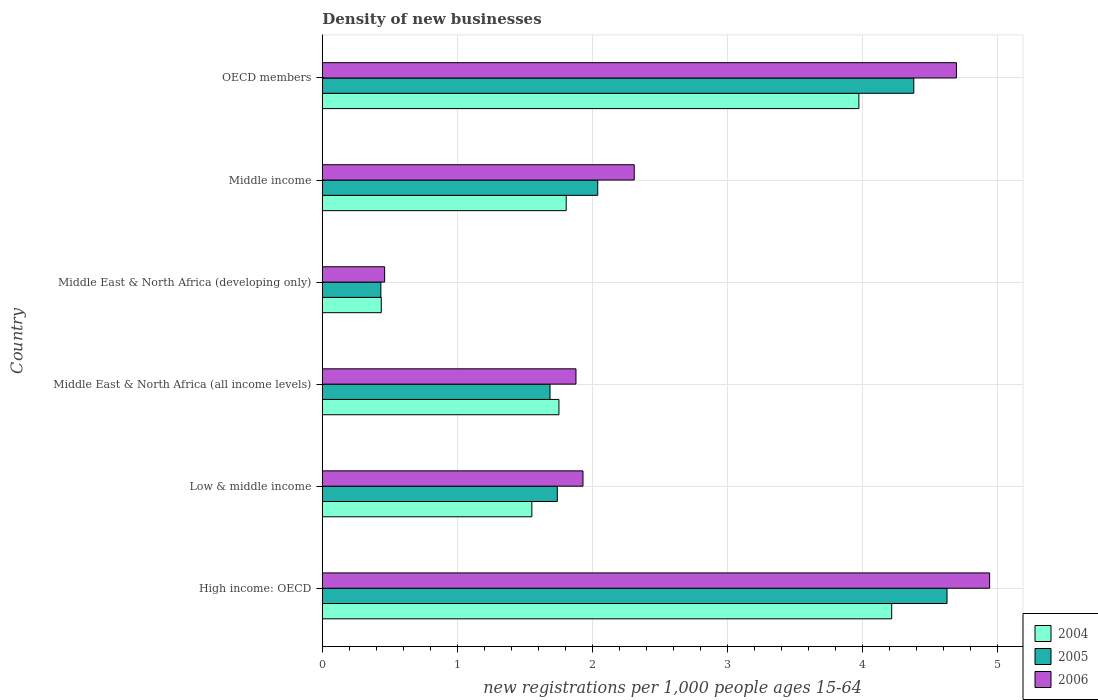Are the number of bars on each tick of the Y-axis equal?
Make the answer very short. Yes. What is the number of new registrations in 2005 in Low & middle income?
Your answer should be very brief. 1.74. Across all countries, what is the maximum number of new registrations in 2004?
Provide a short and direct response. 4.22. Across all countries, what is the minimum number of new registrations in 2006?
Your answer should be very brief. 0.46. In which country was the number of new registrations in 2005 maximum?
Make the answer very short. High income: OECD. In which country was the number of new registrations in 2005 minimum?
Provide a succinct answer. Middle East & North Africa (developing only). What is the total number of new registrations in 2006 in the graph?
Provide a short and direct response. 16.23. What is the difference between the number of new registrations in 2005 in Low & middle income and that in Middle East & North Africa (developing only)?
Give a very brief answer. 1.31. What is the difference between the number of new registrations in 2005 in Middle income and the number of new registrations in 2006 in OECD members?
Provide a short and direct response. -2.66. What is the average number of new registrations in 2006 per country?
Your answer should be compact. 2.7. What is the difference between the number of new registrations in 2004 and number of new registrations in 2005 in High income: OECD?
Give a very brief answer. -0.41. What is the ratio of the number of new registrations in 2005 in Middle East & North Africa (developing only) to that in OECD members?
Make the answer very short. 0.1. Is the number of new registrations in 2004 in Middle East & North Africa (developing only) less than that in Middle income?
Offer a terse response. Yes. What is the difference between the highest and the second highest number of new registrations in 2005?
Ensure brevity in your answer.  0.25. What is the difference between the highest and the lowest number of new registrations in 2004?
Your answer should be very brief. 3.78. Is the sum of the number of new registrations in 2005 in Low & middle income and Middle East & North Africa (developing only) greater than the maximum number of new registrations in 2006 across all countries?
Offer a terse response. No. What does the 3rd bar from the top in Middle East & North Africa (developing only) represents?
Ensure brevity in your answer.  2004. Is it the case that in every country, the sum of the number of new registrations in 2005 and number of new registrations in 2004 is greater than the number of new registrations in 2006?
Offer a terse response. Yes. Are all the bars in the graph horizontal?
Ensure brevity in your answer.  Yes. How many countries are there in the graph?
Give a very brief answer. 6. What is the difference between two consecutive major ticks on the X-axis?
Provide a succinct answer. 1. Where does the legend appear in the graph?
Give a very brief answer. Bottom right. What is the title of the graph?
Your answer should be very brief. Density of new businesses. What is the label or title of the X-axis?
Offer a very short reply. New registrations per 1,0 people ages 15-64. What is the label or title of the Y-axis?
Offer a terse response. Country. What is the new registrations per 1,000 people ages 15-64 in 2004 in High income: OECD?
Give a very brief answer. 4.22. What is the new registrations per 1,000 people ages 15-64 of 2005 in High income: OECD?
Provide a succinct answer. 4.63. What is the new registrations per 1,000 people ages 15-64 of 2006 in High income: OECD?
Provide a short and direct response. 4.94. What is the new registrations per 1,000 people ages 15-64 in 2004 in Low & middle income?
Offer a terse response. 1.55. What is the new registrations per 1,000 people ages 15-64 in 2005 in Low & middle income?
Your response must be concise. 1.74. What is the new registrations per 1,000 people ages 15-64 of 2006 in Low & middle income?
Your answer should be very brief. 1.93. What is the new registrations per 1,000 people ages 15-64 of 2004 in Middle East & North Africa (all income levels)?
Make the answer very short. 1.75. What is the new registrations per 1,000 people ages 15-64 of 2005 in Middle East & North Africa (all income levels)?
Provide a succinct answer. 1.69. What is the new registrations per 1,000 people ages 15-64 in 2006 in Middle East & North Africa (all income levels)?
Make the answer very short. 1.88. What is the new registrations per 1,000 people ages 15-64 in 2004 in Middle East & North Africa (developing only)?
Provide a short and direct response. 0.44. What is the new registrations per 1,000 people ages 15-64 of 2005 in Middle East & North Africa (developing only)?
Your answer should be very brief. 0.43. What is the new registrations per 1,000 people ages 15-64 of 2006 in Middle East & North Africa (developing only)?
Keep it short and to the point. 0.46. What is the new registrations per 1,000 people ages 15-64 in 2004 in Middle income?
Your response must be concise. 1.81. What is the new registrations per 1,000 people ages 15-64 of 2005 in Middle income?
Provide a short and direct response. 2.04. What is the new registrations per 1,000 people ages 15-64 of 2006 in Middle income?
Provide a short and direct response. 2.31. What is the new registrations per 1,000 people ages 15-64 of 2004 in OECD members?
Your answer should be very brief. 3.98. What is the new registrations per 1,000 people ages 15-64 in 2005 in OECD members?
Ensure brevity in your answer.  4.38. What is the new registrations per 1,000 people ages 15-64 in 2006 in OECD members?
Ensure brevity in your answer.  4.7. Across all countries, what is the maximum new registrations per 1,000 people ages 15-64 in 2004?
Offer a terse response. 4.22. Across all countries, what is the maximum new registrations per 1,000 people ages 15-64 of 2005?
Offer a very short reply. 4.63. Across all countries, what is the maximum new registrations per 1,000 people ages 15-64 of 2006?
Provide a short and direct response. 4.94. Across all countries, what is the minimum new registrations per 1,000 people ages 15-64 in 2004?
Your answer should be very brief. 0.44. Across all countries, what is the minimum new registrations per 1,000 people ages 15-64 of 2005?
Your response must be concise. 0.43. Across all countries, what is the minimum new registrations per 1,000 people ages 15-64 of 2006?
Your response must be concise. 0.46. What is the total new registrations per 1,000 people ages 15-64 of 2004 in the graph?
Offer a terse response. 13.74. What is the total new registrations per 1,000 people ages 15-64 of 2005 in the graph?
Your answer should be compact. 14.92. What is the total new registrations per 1,000 people ages 15-64 in 2006 in the graph?
Your answer should be very brief. 16.23. What is the difference between the new registrations per 1,000 people ages 15-64 of 2004 in High income: OECD and that in Low & middle income?
Your response must be concise. 2.67. What is the difference between the new registrations per 1,000 people ages 15-64 in 2005 in High income: OECD and that in Low & middle income?
Offer a terse response. 2.89. What is the difference between the new registrations per 1,000 people ages 15-64 in 2006 in High income: OECD and that in Low & middle income?
Provide a succinct answer. 3.01. What is the difference between the new registrations per 1,000 people ages 15-64 in 2004 in High income: OECD and that in Middle East & North Africa (all income levels)?
Your answer should be compact. 2.47. What is the difference between the new registrations per 1,000 people ages 15-64 of 2005 in High income: OECD and that in Middle East & North Africa (all income levels)?
Give a very brief answer. 2.94. What is the difference between the new registrations per 1,000 people ages 15-64 in 2006 in High income: OECD and that in Middle East & North Africa (all income levels)?
Provide a succinct answer. 3.07. What is the difference between the new registrations per 1,000 people ages 15-64 of 2004 in High income: OECD and that in Middle East & North Africa (developing only)?
Offer a terse response. 3.78. What is the difference between the new registrations per 1,000 people ages 15-64 of 2005 in High income: OECD and that in Middle East & North Africa (developing only)?
Provide a succinct answer. 4.2. What is the difference between the new registrations per 1,000 people ages 15-64 in 2006 in High income: OECD and that in Middle East & North Africa (developing only)?
Keep it short and to the point. 4.48. What is the difference between the new registrations per 1,000 people ages 15-64 in 2004 in High income: OECD and that in Middle income?
Your answer should be compact. 2.41. What is the difference between the new registrations per 1,000 people ages 15-64 in 2005 in High income: OECD and that in Middle income?
Offer a terse response. 2.59. What is the difference between the new registrations per 1,000 people ages 15-64 in 2006 in High income: OECD and that in Middle income?
Offer a very short reply. 2.63. What is the difference between the new registrations per 1,000 people ages 15-64 in 2004 in High income: OECD and that in OECD members?
Give a very brief answer. 0.24. What is the difference between the new registrations per 1,000 people ages 15-64 in 2005 in High income: OECD and that in OECD members?
Provide a succinct answer. 0.25. What is the difference between the new registrations per 1,000 people ages 15-64 in 2006 in High income: OECD and that in OECD members?
Keep it short and to the point. 0.25. What is the difference between the new registrations per 1,000 people ages 15-64 of 2004 in Low & middle income and that in Middle East & North Africa (all income levels)?
Offer a terse response. -0.2. What is the difference between the new registrations per 1,000 people ages 15-64 in 2005 in Low & middle income and that in Middle East & North Africa (all income levels)?
Give a very brief answer. 0.05. What is the difference between the new registrations per 1,000 people ages 15-64 of 2006 in Low & middle income and that in Middle East & North Africa (all income levels)?
Keep it short and to the point. 0.05. What is the difference between the new registrations per 1,000 people ages 15-64 of 2004 in Low & middle income and that in Middle East & North Africa (developing only)?
Give a very brief answer. 1.12. What is the difference between the new registrations per 1,000 people ages 15-64 of 2005 in Low & middle income and that in Middle East & North Africa (developing only)?
Keep it short and to the point. 1.31. What is the difference between the new registrations per 1,000 people ages 15-64 in 2006 in Low & middle income and that in Middle East & North Africa (developing only)?
Provide a succinct answer. 1.47. What is the difference between the new registrations per 1,000 people ages 15-64 of 2004 in Low & middle income and that in Middle income?
Offer a terse response. -0.25. What is the difference between the new registrations per 1,000 people ages 15-64 in 2005 in Low & middle income and that in Middle income?
Provide a succinct answer. -0.3. What is the difference between the new registrations per 1,000 people ages 15-64 of 2006 in Low & middle income and that in Middle income?
Offer a terse response. -0.38. What is the difference between the new registrations per 1,000 people ages 15-64 in 2004 in Low & middle income and that in OECD members?
Your answer should be very brief. -2.42. What is the difference between the new registrations per 1,000 people ages 15-64 of 2005 in Low & middle income and that in OECD members?
Provide a short and direct response. -2.64. What is the difference between the new registrations per 1,000 people ages 15-64 in 2006 in Low & middle income and that in OECD members?
Ensure brevity in your answer.  -2.77. What is the difference between the new registrations per 1,000 people ages 15-64 of 2004 in Middle East & North Africa (all income levels) and that in Middle East & North Africa (developing only)?
Provide a short and direct response. 1.32. What is the difference between the new registrations per 1,000 people ages 15-64 of 2005 in Middle East & North Africa (all income levels) and that in Middle East & North Africa (developing only)?
Ensure brevity in your answer.  1.25. What is the difference between the new registrations per 1,000 people ages 15-64 of 2006 in Middle East & North Africa (all income levels) and that in Middle East & North Africa (developing only)?
Provide a succinct answer. 1.42. What is the difference between the new registrations per 1,000 people ages 15-64 in 2004 in Middle East & North Africa (all income levels) and that in Middle income?
Provide a short and direct response. -0.05. What is the difference between the new registrations per 1,000 people ages 15-64 of 2005 in Middle East & North Africa (all income levels) and that in Middle income?
Offer a very short reply. -0.35. What is the difference between the new registrations per 1,000 people ages 15-64 in 2006 in Middle East & North Africa (all income levels) and that in Middle income?
Make the answer very short. -0.43. What is the difference between the new registrations per 1,000 people ages 15-64 in 2004 in Middle East & North Africa (all income levels) and that in OECD members?
Provide a succinct answer. -2.22. What is the difference between the new registrations per 1,000 people ages 15-64 of 2005 in Middle East & North Africa (all income levels) and that in OECD members?
Give a very brief answer. -2.7. What is the difference between the new registrations per 1,000 people ages 15-64 in 2006 in Middle East & North Africa (all income levels) and that in OECD members?
Give a very brief answer. -2.82. What is the difference between the new registrations per 1,000 people ages 15-64 in 2004 in Middle East & North Africa (developing only) and that in Middle income?
Ensure brevity in your answer.  -1.37. What is the difference between the new registrations per 1,000 people ages 15-64 of 2005 in Middle East & North Africa (developing only) and that in Middle income?
Your response must be concise. -1.61. What is the difference between the new registrations per 1,000 people ages 15-64 in 2006 in Middle East & North Africa (developing only) and that in Middle income?
Keep it short and to the point. -1.85. What is the difference between the new registrations per 1,000 people ages 15-64 of 2004 in Middle East & North Africa (developing only) and that in OECD members?
Your answer should be compact. -3.54. What is the difference between the new registrations per 1,000 people ages 15-64 in 2005 in Middle East & North Africa (developing only) and that in OECD members?
Offer a very short reply. -3.95. What is the difference between the new registrations per 1,000 people ages 15-64 in 2006 in Middle East & North Africa (developing only) and that in OECD members?
Offer a terse response. -4.24. What is the difference between the new registrations per 1,000 people ages 15-64 in 2004 in Middle income and that in OECD members?
Your response must be concise. -2.17. What is the difference between the new registrations per 1,000 people ages 15-64 of 2005 in Middle income and that in OECD members?
Offer a terse response. -2.34. What is the difference between the new registrations per 1,000 people ages 15-64 in 2006 in Middle income and that in OECD members?
Make the answer very short. -2.39. What is the difference between the new registrations per 1,000 people ages 15-64 in 2004 in High income: OECD and the new registrations per 1,000 people ages 15-64 in 2005 in Low & middle income?
Offer a very short reply. 2.48. What is the difference between the new registrations per 1,000 people ages 15-64 of 2004 in High income: OECD and the new registrations per 1,000 people ages 15-64 of 2006 in Low & middle income?
Your answer should be compact. 2.29. What is the difference between the new registrations per 1,000 people ages 15-64 in 2005 in High income: OECD and the new registrations per 1,000 people ages 15-64 in 2006 in Low & middle income?
Your response must be concise. 2.7. What is the difference between the new registrations per 1,000 people ages 15-64 of 2004 in High income: OECD and the new registrations per 1,000 people ages 15-64 of 2005 in Middle East & North Africa (all income levels)?
Provide a succinct answer. 2.53. What is the difference between the new registrations per 1,000 people ages 15-64 of 2004 in High income: OECD and the new registrations per 1,000 people ages 15-64 of 2006 in Middle East & North Africa (all income levels)?
Provide a short and direct response. 2.34. What is the difference between the new registrations per 1,000 people ages 15-64 in 2005 in High income: OECD and the new registrations per 1,000 people ages 15-64 in 2006 in Middle East & North Africa (all income levels)?
Your answer should be very brief. 2.75. What is the difference between the new registrations per 1,000 people ages 15-64 of 2004 in High income: OECD and the new registrations per 1,000 people ages 15-64 of 2005 in Middle East & North Africa (developing only)?
Give a very brief answer. 3.79. What is the difference between the new registrations per 1,000 people ages 15-64 in 2004 in High income: OECD and the new registrations per 1,000 people ages 15-64 in 2006 in Middle East & North Africa (developing only)?
Provide a short and direct response. 3.76. What is the difference between the new registrations per 1,000 people ages 15-64 in 2005 in High income: OECD and the new registrations per 1,000 people ages 15-64 in 2006 in Middle East & North Africa (developing only)?
Make the answer very short. 4.17. What is the difference between the new registrations per 1,000 people ages 15-64 of 2004 in High income: OECD and the new registrations per 1,000 people ages 15-64 of 2005 in Middle income?
Make the answer very short. 2.18. What is the difference between the new registrations per 1,000 people ages 15-64 of 2004 in High income: OECD and the new registrations per 1,000 people ages 15-64 of 2006 in Middle income?
Provide a short and direct response. 1.91. What is the difference between the new registrations per 1,000 people ages 15-64 of 2005 in High income: OECD and the new registrations per 1,000 people ages 15-64 of 2006 in Middle income?
Provide a succinct answer. 2.32. What is the difference between the new registrations per 1,000 people ages 15-64 in 2004 in High income: OECD and the new registrations per 1,000 people ages 15-64 in 2005 in OECD members?
Ensure brevity in your answer.  -0.16. What is the difference between the new registrations per 1,000 people ages 15-64 of 2004 in High income: OECD and the new registrations per 1,000 people ages 15-64 of 2006 in OECD members?
Ensure brevity in your answer.  -0.48. What is the difference between the new registrations per 1,000 people ages 15-64 in 2005 in High income: OECD and the new registrations per 1,000 people ages 15-64 in 2006 in OECD members?
Provide a succinct answer. -0.07. What is the difference between the new registrations per 1,000 people ages 15-64 in 2004 in Low & middle income and the new registrations per 1,000 people ages 15-64 in 2005 in Middle East & North Africa (all income levels)?
Ensure brevity in your answer.  -0.13. What is the difference between the new registrations per 1,000 people ages 15-64 of 2004 in Low & middle income and the new registrations per 1,000 people ages 15-64 of 2006 in Middle East & North Africa (all income levels)?
Give a very brief answer. -0.33. What is the difference between the new registrations per 1,000 people ages 15-64 of 2005 in Low & middle income and the new registrations per 1,000 people ages 15-64 of 2006 in Middle East & North Africa (all income levels)?
Offer a very short reply. -0.14. What is the difference between the new registrations per 1,000 people ages 15-64 of 2004 in Low & middle income and the new registrations per 1,000 people ages 15-64 of 2005 in Middle East & North Africa (developing only)?
Ensure brevity in your answer.  1.12. What is the difference between the new registrations per 1,000 people ages 15-64 in 2005 in Low & middle income and the new registrations per 1,000 people ages 15-64 in 2006 in Middle East & North Africa (developing only)?
Ensure brevity in your answer.  1.28. What is the difference between the new registrations per 1,000 people ages 15-64 of 2004 in Low & middle income and the new registrations per 1,000 people ages 15-64 of 2005 in Middle income?
Your response must be concise. -0.49. What is the difference between the new registrations per 1,000 people ages 15-64 of 2004 in Low & middle income and the new registrations per 1,000 people ages 15-64 of 2006 in Middle income?
Your answer should be very brief. -0.76. What is the difference between the new registrations per 1,000 people ages 15-64 of 2005 in Low & middle income and the new registrations per 1,000 people ages 15-64 of 2006 in Middle income?
Your answer should be compact. -0.57. What is the difference between the new registrations per 1,000 people ages 15-64 of 2004 in Low & middle income and the new registrations per 1,000 people ages 15-64 of 2005 in OECD members?
Give a very brief answer. -2.83. What is the difference between the new registrations per 1,000 people ages 15-64 in 2004 in Low & middle income and the new registrations per 1,000 people ages 15-64 in 2006 in OECD members?
Give a very brief answer. -3.15. What is the difference between the new registrations per 1,000 people ages 15-64 of 2005 in Low & middle income and the new registrations per 1,000 people ages 15-64 of 2006 in OECD members?
Offer a terse response. -2.96. What is the difference between the new registrations per 1,000 people ages 15-64 of 2004 in Middle East & North Africa (all income levels) and the new registrations per 1,000 people ages 15-64 of 2005 in Middle East & North Africa (developing only)?
Make the answer very short. 1.32. What is the difference between the new registrations per 1,000 people ages 15-64 of 2004 in Middle East & North Africa (all income levels) and the new registrations per 1,000 people ages 15-64 of 2006 in Middle East & North Africa (developing only)?
Provide a short and direct response. 1.29. What is the difference between the new registrations per 1,000 people ages 15-64 of 2005 in Middle East & North Africa (all income levels) and the new registrations per 1,000 people ages 15-64 of 2006 in Middle East & North Africa (developing only)?
Keep it short and to the point. 1.23. What is the difference between the new registrations per 1,000 people ages 15-64 of 2004 in Middle East & North Africa (all income levels) and the new registrations per 1,000 people ages 15-64 of 2005 in Middle income?
Your answer should be compact. -0.29. What is the difference between the new registrations per 1,000 people ages 15-64 of 2004 in Middle East & North Africa (all income levels) and the new registrations per 1,000 people ages 15-64 of 2006 in Middle income?
Offer a terse response. -0.56. What is the difference between the new registrations per 1,000 people ages 15-64 in 2005 in Middle East & North Africa (all income levels) and the new registrations per 1,000 people ages 15-64 in 2006 in Middle income?
Your response must be concise. -0.62. What is the difference between the new registrations per 1,000 people ages 15-64 in 2004 in Middle East & North Africa (all income levels) and the new registrations per 1,000 people ages 15-64 in 2005 in OECD members?
Your answer should be compact. -2.63. What is the difference between the new registrations per 1,000 people ages 15-64 of 2004 in Middle East & North Africa (all income levels) and the new registrations per 1,000 people ages 15-64 of 2006 in OECD members?
Your answer should be very brief. -2.95. What is the difference between the new registrations per 1,000 people ages 15-64 of 2005 in Middle East & North Africa (all income levels) and the new registrations per 1,000 people ages 15-64 of 2006 in OECD members?
Offer a very short reply. -3.01. What is the difference between the new registrations per 1,000 people ages 15-64 of 2004 in Middle East & North Africa (developing only) and the new registrations per 1,000 people ages 15-64 of 2005 in Middle income?
Your response must be concise. -1.6. What is the difference between the new registrations per 1,000 people ages 15-64 of 2004 in Middle East & North Africa (developing only) and the new registrations per 1,000 people ages 15-64 of 2006 in Middle income?
Offer a terse response. -1.87. What is the difference between the new registrations per 1,000 people ages 15-64 of 2005 in Middle East & North Africa (developing only) and the new registrations per 1,000 people ages 15-64 of 2006 in Middle income?
Make the answer very short. -1.88. What is the difference between the new registrations per 1,000 people ages 15-64 of 2004 in Middle East & North Africa (developing only) and the new registrations per 1,000 people ages 15-64 of 2005 in OECD members?
Your answer should be very brief. -3.95. What is the difference between the new registrations per 1,000 people ages 15-64 of 2004 in Middle East & North Africa (developing only) and the new registrations per 1,000 people ages 15-64 of 2006 in OECD members?
Keep it short and to the point. -4.26. What is the difference between the new registrations per 1,000 people ages 15-64 of 2005 in Middle East & North Africa (developing only) and the new registrations per 1,000 people ages 15-64 of 2006 in OECD members?
Make the answer very short. -4.26. What is the difference between the new registrations per 1,000 people ages 15-64 of 2004 in Middle income and the new registrations per 1,000 people ages 15-64 of 2005 in OECD members?
Offer a terse response. -2.58. What is the difference between the new registrations per 1,000 people ages 15-64 in 2004 in Middle income and the new registrations per 1,000 people ages 15-64 in 2006 in OECD members?
Provide a succinct answer. -2.89. What is the difference between the new registrations per 1,000 people ages 15-64 in 2005 in Middle income and the new registrations per 1,000 people ages 15-64 in 2006 in OECD members?
Provide a succinct answer. -2.66. What is the average new registrations per 1,000 people ages 15-64 of 2004 per country?
Your answer should be compact. 2.29. What is the average new registrations per 1,000 people ages 15-64 in 2005 per country?
Offer a terse response. 2.49. What is the average new registrations per 1,000 people ages 15-64 of 2006 per country?
Give a very brief answer. 2.7. What is the difference between the new registrations per 1,000 people ages 15-64 of 2004 and new registrations per 1,000 people ages 15-64 of 2005 in High income: OECD?
Your answer should be compact. -0.41. What is the difference between the new registrations per 1,000 people ages 15-64 of 2004 and new registrations per 1,000 people ages 15-64 of 2006 in High income: OECD?
Your response must be concise. -0.73. What is the difference between the new registrations per 1,000 people ages 15-64 in 2005 and new registrations per 1,000 people ages 15-64 in 2006 in High income: OECD?
Your answer should be very brief. -0.32. What is the difference between the new registrations per 1,000 people ages 15-64 of 2004 and new registrations per 1,000 people ages 15-64 of 2005 in Low & middle income?
Offer a very short reply. -0.19. What is the difference between the new registrations per 1,000 people ages 15-64 in 2004 and new registrations per 1,000 people ages 15-64 in 2006 in Low & middle income?
Give a very brief answer. -0.38. What is the difference between the new registrations per 1,000 people ages 15-64 in 2005 and new registrations per 1,000 people ages 15-64 in 2006 in Low & middle income?
Your response must be concise. -0.19. What is the difference between the new registrations per 1,000 people ages 15-64 in 2004 and new registrations per 1,000 people ages 15-64 in 2005 in Middle East & North Africa (all income levels)?
Give a very brief answer. 0.07. What is the difference between the new registrations per 1,000 people ages 15-64 of 2004 and new registrations per 1,000 people ages 15-64 of 2006 in Middle East & North Africa (all income levels)?
Offer a very short reply. -0.13. What is the difference between the new registrations per 1,000 people ages 15-64 of 2005 and new registrations per 1,000 people ages 15-64 of 2006 in Middle East & North Africa (all income levels)?
Provide a succinct answer. -0.19. What is the difference between the new registrations per 1,000 people ages 15-64 in 2004 and new registrations per 1,000 people ages 15-64 in 2005 in Middle East & North Africa (developing only)?
Your answer should be compact. 0. What is the difference between the new registrations per 1,000 people ages 15-64 of 2004 and new registrations per 1,000 people ages 15-64 of 2006 in Middle East & North Africa (developing only)?
Give a very brief answer. -0.02. What is the difference between the new registrations per 1,000 people ages 15-64 in 2005 and new registrations per 1,000 people ages 15-64 in 2006 in Middle East & North Africa (developing only)?
Ensure brevity in your answer.  -0.03. What is the difference between the new registrations per 1,000 people ages 15-64 in 2004 and new registrations per 1,000 people ages 15-64 in 2005 in Middle income?
Your response must be concise. -0.23. What is the difference between the new registrations per 1,000 people ages 15-64 of 2004 and new registrations per 1,000 people ages 15-64 of 2006 in Middle income?
Your answer should be very brief. -0.5. What is the difference between the new registrations per 1,000 people ages 15-64 in 2005 and new registrations per 1,000 people ages 15-64 in 2006 in Middle income?
Make the answer very short. -0.27. What is the difference between the new registrations per 1,000 people ages 15-64 of 2004 and new registrations per 1,000 people ages 15-64 of 2005 in OECD members?
Your answer should be very brief. -0.41. What is the difference between the new registrations per 1,000 people ages 15-64 in 2004 and new registrations per 1,000 people ages 15-64 in 2006 in OECD members?
Offer a very short reply. -0.72. What is the difference between the new registrations per 1,000 people ages 15-64 in 2005 and new registrations per 1,000 people ages 15-64 in 2006 in OECD members?
Provide a succinct answer. -0.32. What is the ratio of the new registrations per 1,000 people ages 15-64 in 2004 in High income: OECD to that in Low & middle income?
Your answer should be very brief. 2.72. What is the ratio of the new registrations per 1,000 people ages 15-64 in 2005 in High income: OECD to that in Low & middle income?
Provide a succinct answer. 2.66. What is the ratio of the new registrations per 1,000 people ages 15-64 of 2006 in High income: OECD to that in Low & middle income?
Your answer should be compact. 2.56. What is the ratio of the new registrations per 1,000 people ages 15-64 in 2004 in High income: OECD to that in Middle East & North Africa (all income levels)?
Ensure brevity in your answer.  2.41. What is the ratio of the new registrations per 1,000 people ages 15-64 of 2005 in High income: OECD to that in Middle East & North Africa (all income levels)?
Provide a succinct answer. 2.74. What is the ratio of the new registrations per 1,000 people ages 15-64 in 2006 in High income: OECD to that in Middle East & North Africa (all income levels)?
Provide a succinct answer. 2.63. What is the ratio of the new registrations per 1,000 people ages 15-64 in 2004 in High income: OECD to that in Middle East & North Africa (developing only)?
Your answer should be very brief. 9.66. What is the ratio of the new registrations per 1,000 people ages 15-64 of 2005 in High income: OECD to that in Middle East & North Africa (developing only)?
Your answer should be compact. 10.67. What is the ratio of the new registrations per 1,000 people ages 15-64 of 2006 in High income: OECD to that in Middle East & North Africa (developing only)?
Your answer should be very brief. 10.71. What is the ratio of the new registrations per 1,000 people ages 15-64 of 2004 in High income: OECD to that in Middle income?
Keep it short and to the point. 2.33. What is the ratio of the new registrations per 1,000 people ages 15-64 of 2005 in High income: OECD to that in Middle income?
Your answer should be very brief. 2.27. What is the ratio of the new registrations per 1,000 people ages 15-64 of 2006 in High income: OECD to that in Middle income?
Provide a short and direct response. 2.14. What is the ratio of the new registrations per 1,000 people ages 15-64 of 2004 in High income: OECD to that in OECD members?
Your response must be concise. 1.06. What is the ratio of the new registrations per 1,000 people ages 15-64 of 2005 in High income: OECD to that in OECD members?
Provide a short and direct response. 1.06. What is the ratio of the new registrations per 1,000 people ages 15-64 in 2006 in High income: OECD to that in OECD members?
Provide a succinct answer. 1.05. What is the ratio of the new registrations per 1,000 people ages 15-64 in 2004 in Low & middle income to that in Middle East & North Africa (all income levels)?
Make the answer very short. 0.89. What is the ratio of the new registrations per 1,000 people ages 15-64 in 2005 in Low & middle income to that in Middle East & North Africa (all income levels)?
Your response must be concise. 1.03. What is the ratio of the new registrations per 1,000 people ages 15-64 in 2006 in Low & middle income to that in Middle East & North Africa (all income levels)?
Keep it short and to the point. 1.03. What is the ratio of the new registrations per 1,000 people ages 15-64 in 2004 in Low & middle income to that in Middle East & North Africa (developing only)?
Give a very brief answer. 3.55. What is the ratio of the new registrations per 1,000 people ages 15-64 of 2005 in Low & middle income to that in Middle East & North Africa (developing only)?
Your response must be concise. 4.01. What is the ratio of the new registrations per 1,000 people ages 15-64 of 2006 in Low & middle income to that in Middle East & North Africa (developing only)?
Offer a terse response. 4.18. What is the ratio of the new registrations per 1,000 people ages 15-64 in 2004 in Low & middle income to that in Middle income?
Your answer should be very brief. 0.86. What is the ratio of the new registrations per 1,000 people ages 15-64 in 2005 in Low & middle income to that in Middle income?
Keep it short and to the point. 0.85. What is the ratio of the new registrations per 1,000 people ages 15-64 in 2006 in Low & middle income to that in Middle income?
Provide a succinct answer. 0.84. What is the ratio of the new registrations per 1,000 people ages 15-64 of 2004 in Low & middle income to that in OECD members?
Make the answer very short. 0.39. What is the ratio of the new registrations per 1,000 people ages 15-64 in 2005 in Low & middle income to that in OECD members?
Ensure brevity in your answer.  0.4. What is the ratio of the new registrations per 1,000 people ages 15-64 of 2006 in Low & middle income to that in OECD members?
Offer a very short reply. 0.41. What is the ratio of the new registrations per 1,000 people ages 15-64 of 2004 in Middle East & North Africa (all income levels) to that in Middle East & North Africa (developing only)?
Ensure brevity in your answer.  4.01. What is the ratio of the new registrations per 1,000 people ages 15-64 in 2005 in Middle East & North Africa (all income levels) to that in Middle East & North Africa (developing only)?
Your response must be concise. 3.89. What is the ratio of the new registrations per 1,000 people ages 15-64 of 2006 in Middle East & North Africa (all income levels) to that in Middle East & North Africa (developing only)?
Make the answer very short. 4.07. What is the ratio of the new registrations per 1,000 people ages 15-64 of 2004 in Middle East & North Africa (all income levels) to that in Middle income?
Give a very brief answer. 0.97. What is the ratio of the new registrations per 1,000 people ages 15-64 of 2005 in Middle East & North Africa (all income levels) to that in Middle income?
Provide a short and direct response. 0.83. What is the ratio of the new registrations per 1,000 people ages 15-64 of 2006 in Middle East & North Africa (all income levels) to that in Middle income?
Offer a terse response. 0.81. What is the ratio of the new registrations per 1,000 people ages 15-64 in 2004 in Middle East & North Africa (all income levels) to that in OECD members?
Your response must be concise. 0.44. What is the ratio of the new registrations per 1,000 people ages 15-64 in 2005 in Middle East & North Africa (all income levels) to that in OECD members?
Ensure brevity in your answer.  0.39. What is the ratio of the new registrations per 1,000 people ages 15-64 of 2004 in Middle East & North Africa (developing only) to that in Middle income?
Make the answer very short. 0.24. What is the ratio of the new registrations per 1,000 people ages 15-64 of 2005 in Middle East & North Africa (developing only) to that in Middle income?
Offer a terse response. 0.21. What is the ratio of the new registrations per 1,000 people ages 15-64 in 2006 in Middle East & North Africa (developing only) to that in Middle income?
Keep it short and to the point. 0.2. What is the ratio of the new registrations per 1,000 people ages 15-64 in 2004 in Middle East & North Africa (developing only) to that in OECD members?
Provide a short and direct response. 0.11. What is the ratio of the new registrations per 1,000 people ages 15-64 of 2005 in Middle East & North Africa (developing only) to that in OECD members?
Give a very brief answer. 0.1. What is the ratio of the new registrations per 1,000 people ages 15-64 in 2006 in Middle East & North Africa (developing only) to that in OECD members?
Keep it short and to the point. 0.1. What is the ratio of the new registrations per 1,000 people ages 15-64 in 2004 in Middle income to that in OECD members?
Offer a terse response. 0.45. What is the ratio of the new registrations per 1,000 people ages 15-64 in 2005 in Middle income to that in OECD members?
Offer a terse response. 0.47. What is the ratio of the new registrations per 1,000 people ages 15-64 of 2006 in Middle income to that in OECD members?
Keep it short and to the point. 0.49. What is the difference between the highest and the second highest new registrations per 1,000 people ages 15-64 of 2004?
Offer a terse response. 0.24. What is the difference between the highest and the second highest new registrations per 1,000 people ages 15-64 in 2005?
Ensure brevity in your answer.  0.25. What is the difference between the highest and the second highest new registrations per 1,000 people ages 15-64 of 2006?
Ensure brevity in your answer.  0.25. What is the difference between the highest and the lowest new registrations per 1,000 people ages 15-64 in 2004?
Offer a terse response. 3.78. What is the difference between the highest and the lowest new registrations per 1,000 people ages 15-64 in 2005?
Your response must be concise. 4.2. What is the difference between the highest and the lowest new registrations per 1,000 people ages 15-64 in 2006?
Provide a short and direct response. 4.48. 